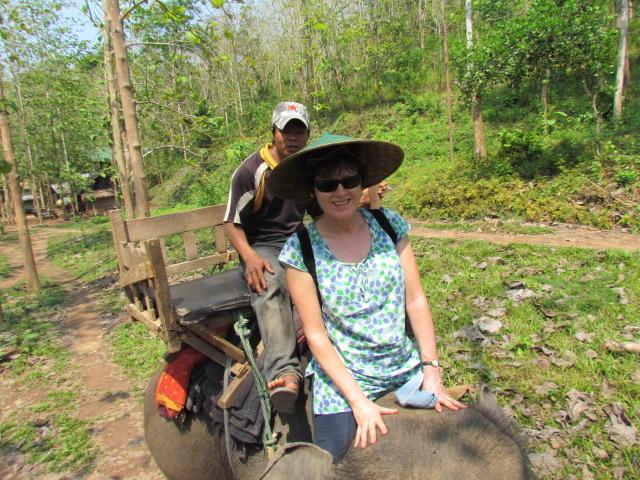How many men are there?
Give a very brief answer. 1. What type of hat is the woman wearing?
Write a very short answer. Sun hat. Does the woman have shade?
Write a very short answer. Yes. Are the people wearing hats?
Concise answer only. Yes. 